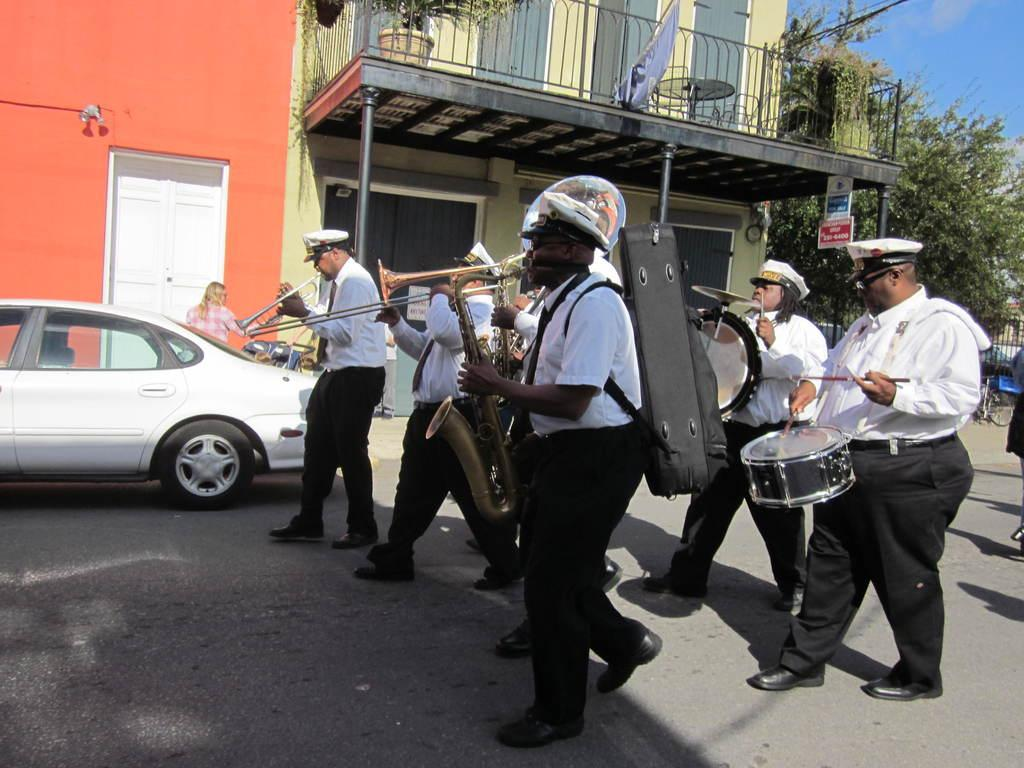What are the people in the image doing? The people in the image are holding musical instruments. How are the people moving in the image? The people are moving on the road. What else can be seen on the road in the image? There is a car parked on the side of the road. What type of structure is visible in the image? There is a building visible in the image. What type of vegetation is present in the image? Trees are present in the image. How would you describe the sky in the image? The sky is blue and cloudy in the image. What type of government is being discussed in the image? There is no discussion or mention of any government in the image. 